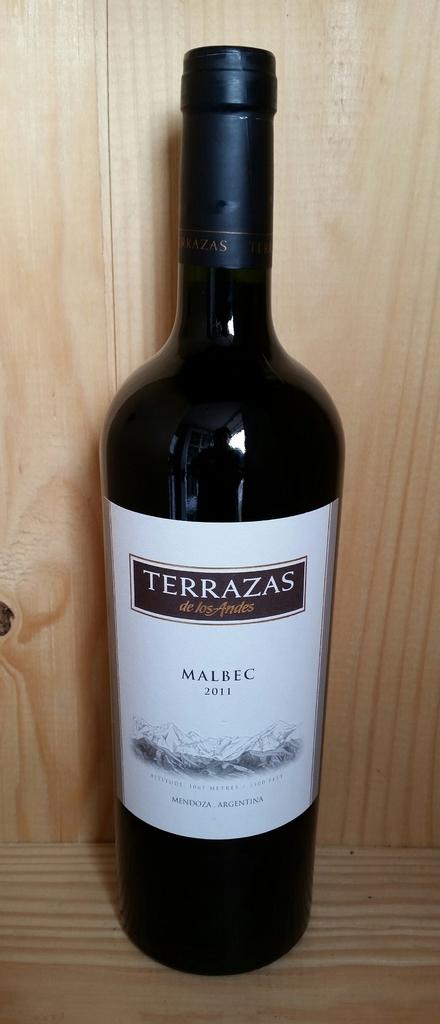What brand is this wine?
Make the answer very short. Terrazas. 